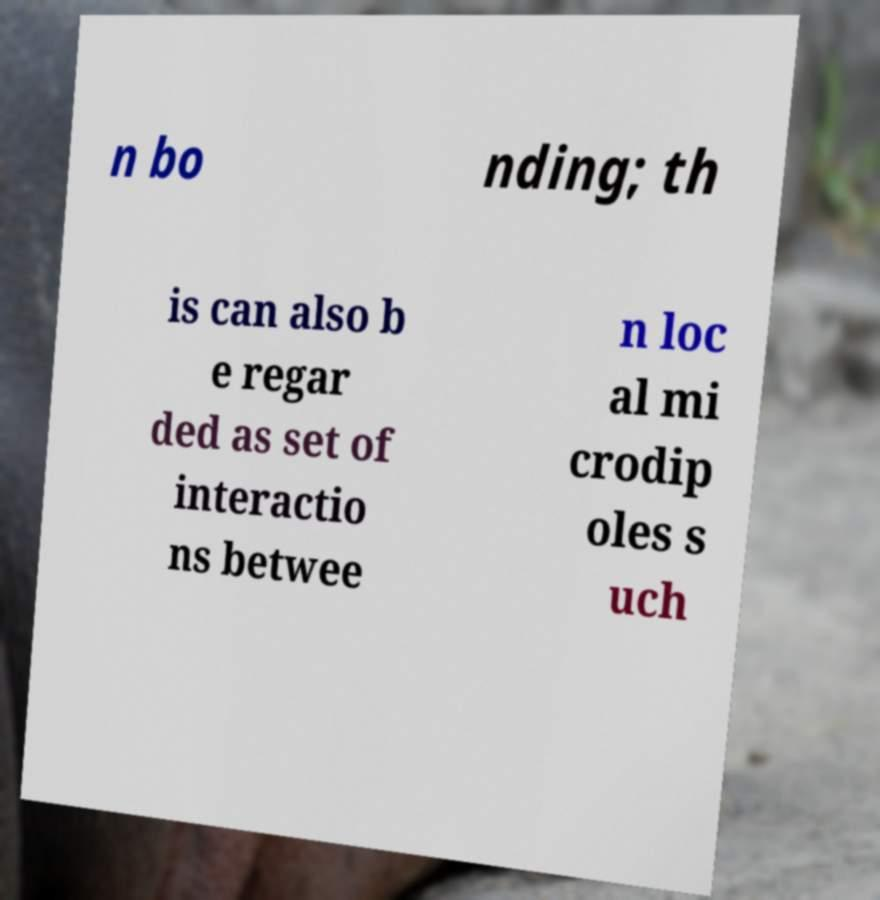Could you extract and type out the text from this image? n bo nding; th is can also b e regar ded as set of interactio ns betwee n loc al mi crodip oles s uch 